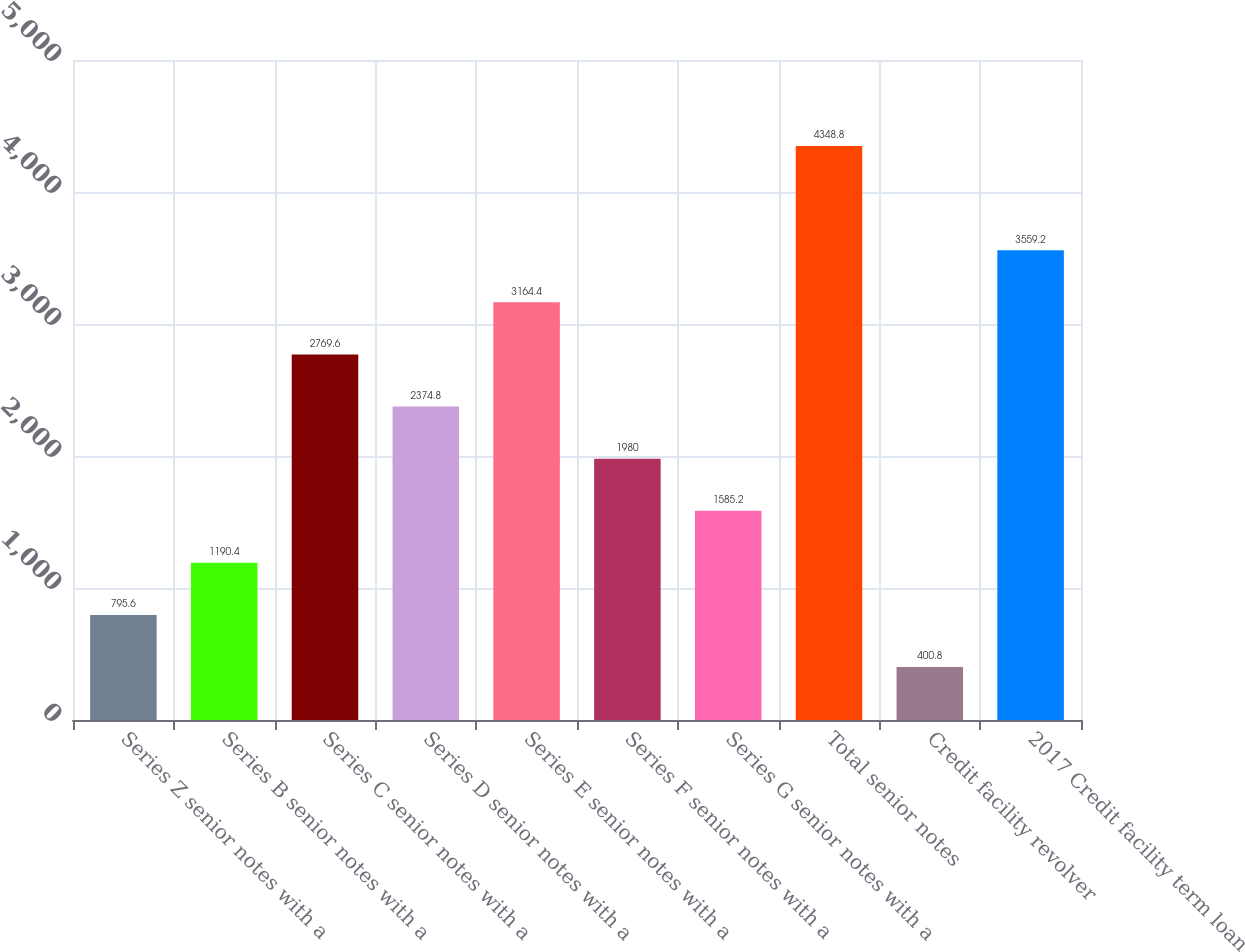<chart> <loc_0><loc_0><loc_500><loc_500><bar_chart><fcel>Series Z senior notes with a<fcel>Series B senior notes with a<fcel>Series C senior notes with a<fcel>Series D senior notes with a<fcel>Series E senior notes with a<fcel>Series F senior notes with a<fcel>Series G senior notes with a<fcel>Total senior notes<fcel>Credit facility revolver<fcel>2017 Credit facility term loan<nl><fcel>795.6<fcel>1190.4<fcel>2769.6<fcel>2374.8<fcel>3164.4<fcel>1980<fcel>1585.2<fcel>4348.8<fcel>400.8<fcel>3559.2<nl></chart> 